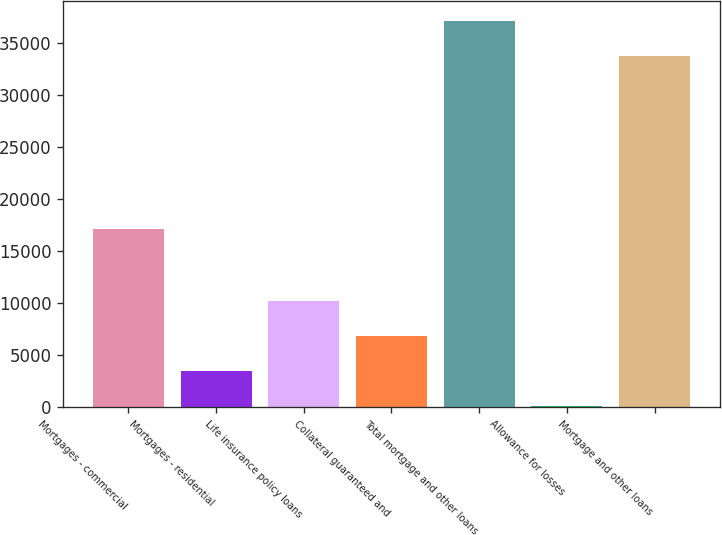<chart> <loc_0><loc_0><loc_500><loc_500><bar_chart><fcel>Mortgages - commercial<fcel>Mortgages - residential<fcel>Life insurance policy loans<fcel>Collateral guaranteed and<fcel>Total mortgage and other loans<fcel>Allowance for losses<fcel>Mortgage and other loans<nl><fcel>17105<fcel>3449.7<fcel>10195.1<fcel>6822.4<fcel>37099.7<fcel>77<fcel>33727<nl></chart> 